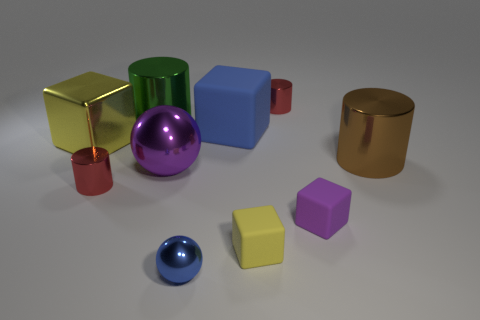Subtract all blue rubber cubes. How many cubes are left? 3 Subtract all purple spheres. How many spheres are left? 1 Subtract all gray balls. How many red cylinders are left? 2 Subtract 1 cubes. How many cubes are left? 3 Subtract 1 brown cylinders. How many objects are left? 9 Subtract all cylinders. How many objects are left? 6 Subtract all red cubes. Subtract all brown balls. How many cubes are left? 4 Subtract all big balls. Subtract all matte blocks. How many objects are left? 6 Add 2 big rubber blocks. How many big rubber blocks are left? 3 Add 3 big green shiny cylinders. How many big green shiny cylinders exist? 4 